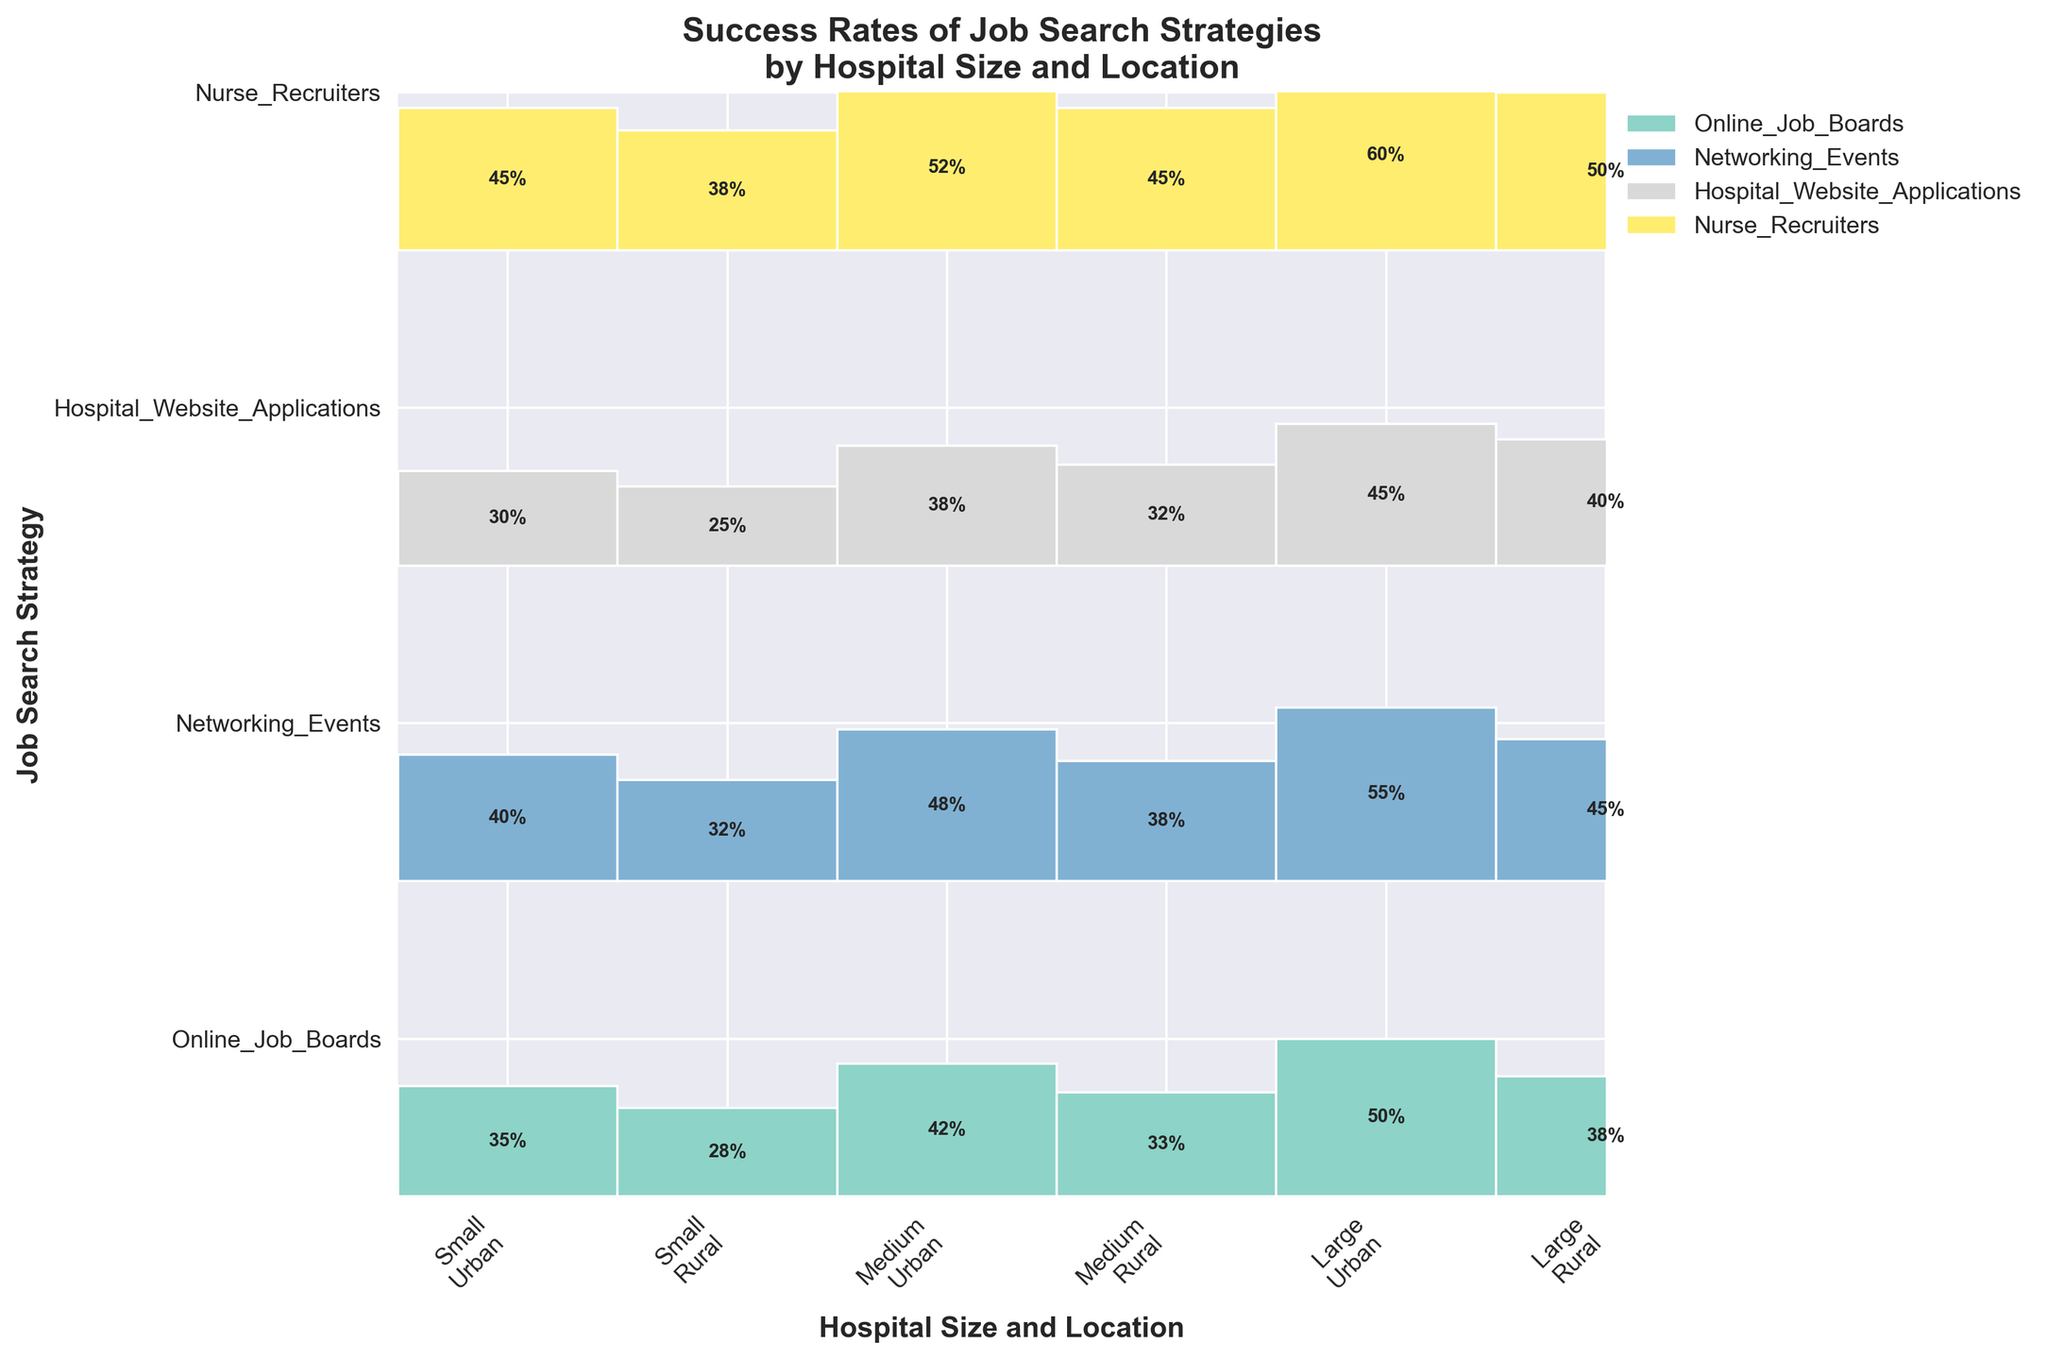Which job search strategy has the highest success rate in large urban hospitals? To find this, locate the 'Large Urban' column of rectangles in the figure and identify the strategy with the highest success rate value. Nurse Recruiters has the highest percentage (60%) here.
Answer: Nurse Recruiters What is the difference in success rates between Online Job Boards and Networking Events in medium urban hospitals? First, find the success rates for these strategies in the 'Medium Urban' column: Online Job Boards (42%) and Networking Events (48%). Subtract the success rate for Online Job Boards from Networking Events: 48% - 42% = 6%.
Answer: 6% Which job search strategy has the lowest success rate in rural hospitals, regardless of size? Check the success rates for all strategies in small, medium, and large rural hospitals. Hospital Website Applications have the lowest rate of 25% in small rural hospitals.
Answer: Hospital Website Applications How do the success rates of Nurse Recruiters compare between small rural and small urban hospitals? Locate the rectangles for Nurse Recruiters in small rural (38%) and small urban (45%) hospitals and compare them. Nurse Recruiters have a higher success rate in small urban hospitals.
Answer: Small urban hospitals have a higher success rate What is the overall trend in success rates for Online Job Boards across different hospital sizes in urban locations? Look at the rectangles for Online Job Boards (35% in small, 42% in medium, 50% in large) in urban locations and observe the pattern. The success rate increases with hospital size.
Answer: The success rate increases with hospital size Which combination of hospital size and location has the highest success rate for Networking Events? Find the highest success rate for Networking Events by checking each combination: Small Urban (40%), Medium Urban (48%), Large Urban (55%), Small Rural (32%), Medium Rural (38%), Large Rural (45%). Large Urban has the highest rate (55%).
Answer: Large Urban What is the average success rate for Hospital Website Applications in urban hospitals? Find the success rates: Small Urban (30%), Medium Urban (38%), Large Urban (45%). Calculate their average: (30% + 38% + 45%) / 3 = 37.67%.
Answer: 37.67% What are the differences in success rates for Online Job Boards between medium urban and medium rural hospitals? Check the success rates for Online Job Boards: Medium Urban (42%), Medium Rural (33%). Subtract the smaller rate from the larger one: 42% - 33% = 9%.
Answer: 9% 